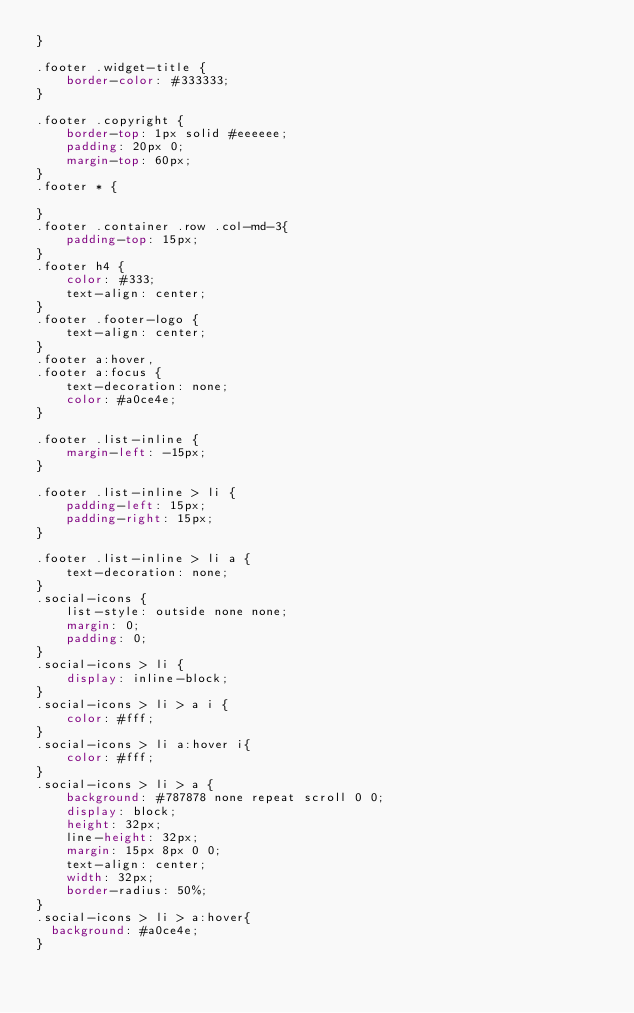<code> <loc_0><loc_0><loc_500><loc_500><_CSS_>}

.footer .widget-title {
    border-color: #333333;
}

.footer .copyright {
    border-top: 1px solid #eeeeee;
    padding: 20px 0;
    margin-top: 60px;
}
.footer * {

}
.footer .container .row .col-md-3{
    padding-top: 15px;
}
.footer h4 {
    color: #333;
    text-align: center;
}
.footer .footer-logo {
    text-align: center;
}
.footer a:hover,
.footer a:focus {
    text-decoration: none;
    color: #a0ce4e;
}

.footer .list-inline {
    margin-left: -15px;
}

.footer .list-inline > li {
    padding-left: 15px;
    padding-right: 15px;
}

.footer .list-inline > li a {
    text-decoration: none;
}
.social-icons {
    list-style: outside none none;
    margin: 0;
    padding: 0;
}
.social-icons > li {
    display: inline-block;
}
.social-icons > li > a i {
    color: #fff;
}
.social-icons > li a:hover i{
    color: #fff;
}
.social-icons > li > a {
    background: #787878 none repeat scroll 0 0;
    display: block;
    height: 32px;
    line-height: 32px;
    margin: 15px 8px 0 0;
    text-align: center;
    width: 32px;
    border-radius: 50%;
}
.social-icons > li > a:hover{
  background: #a0ce4e;
}
</code> 